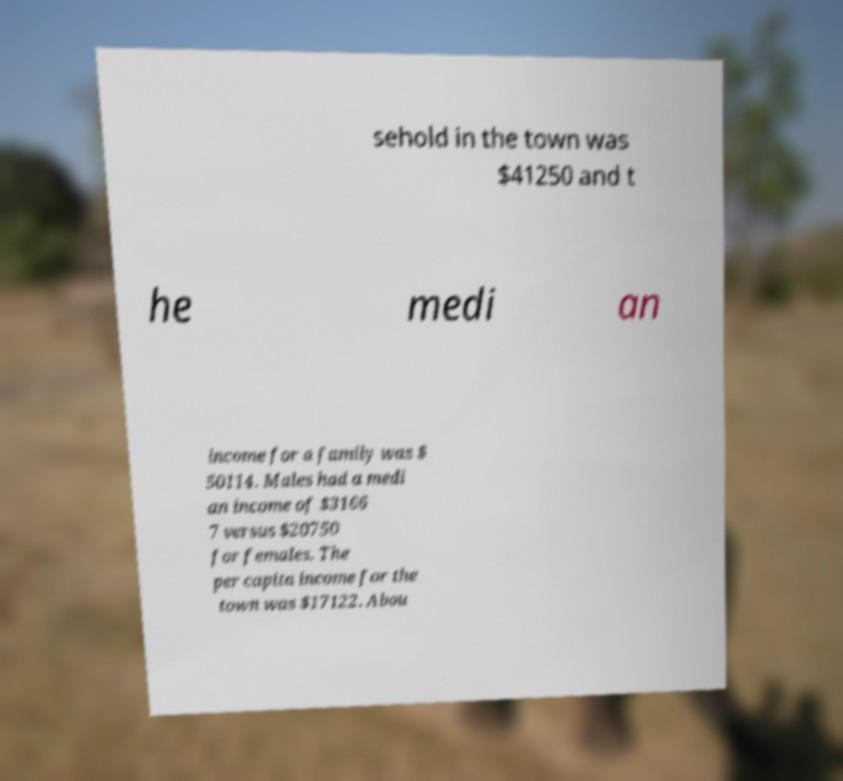For documentation purposes, I need the text within this image transcribed. Could you provide that? sehold in the town was $41250 and t he medi an income for a family was $ 50114. Males had a medi an income of $3166 7 versus $20750 for females. The per capita income for the town was $17122. Abou 